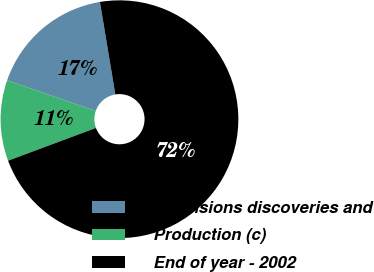Convert chart to OTSL. <chart><loc_0><loc_0><loc_500><loc_500><pie_chart><fcel>Extensions discoveries and<fcel>Production (c)<fcel>End of year - 2002<nl><fcel>17.07%<fcel>10.98%<fcel>71.95%<nl></chart> 